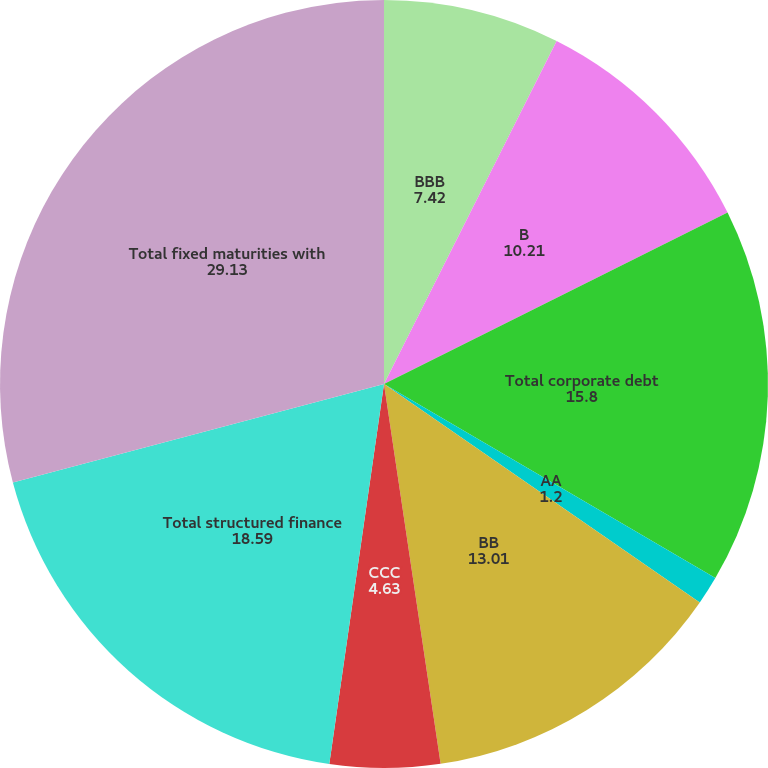<chart> <loc_0><loc_0><loc_500><loc_500><pie_chart><fcel>BBB<fcel>B<fcel>Total corporate debt<fcel>AA<fcel>BB<fcel>CCC<fcel>Total structured finance<fcel>Total fixed maturities with<nl><fcel>7.42%<fcel>10.21%<fcel>15.8%<fcel>1.2%<fcel>13.01%<fcel>4.63%<fcel>18.59%<fcel>29.13%<nl></chart> 